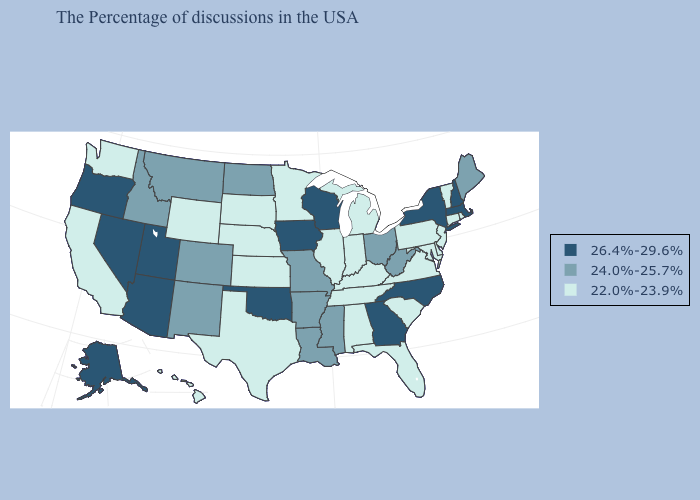Does Minnesota have the lowest value in the USA?
Concise answer only. Yes. What is the value of Arizona?
Quick response, please. 26.4%-29.6%. Name the states that have a value in the range 26.4%-29.6%?
Quick response, please. Massachusetts, New Hampshire, New York, North Carolina, Georgia, Wisconsin, Iowa, Oklahoma, Utah, Arizona, Nevada, Oregon, Alaska. Does Maine have the highest value in the Northeast?
Concise answer only. No. Which states have the lowest value in the USA?
Be succinct. Rhode Island, Vermont, Connecticut, New Jersey, Delaware, Maryland, Pennsylvania, Virginia, South Carolina, Florida, Michigan, Kentucky, Indiana, Alabama, Tennessee, Illinois, Minnesota, Kansas, Nebraska, Texas, South Dakota, Wyoming, California, Washington, Hawaii. Name the states that have a value in the range 22.0%-23.9%?
Be succinct. Rhode Island, Vermont, Connecticut, New Jersey, Delaware, Maryland, Pennsylvania, Virginia, South Carolina, Florida, Michigan, Kentucky, Indiana, Alabama, Tennessee, Illinois, Minnesota, Kansas, Nebraska, Texas, South Dakota, Wyoming, California, Washington, Hawaii. How many symbols are there in the legend?
Keep it brief. 3. What is the value of Illinois?
Write a very short answer. 22.0%-23.9%. Does Wisconsin have the lowest value in the USA?
Keep it brief. No. Does Minnesota have the lowest value in the USA?
Quick response, please. Yes. What is the value of Iowa?
Keep it brief. 26.4%-29.6%. What is the value of Arizona?
Short answer required. 26.4%-29.6%. Does Kentucky have the same value as Oklahoma?
Answer briefly. No. Name the states that have a value in the range 24.0%-25.7%?
Give a very brief answer. Maine, West Virginia, Ohio, Mississippi, Louisiana, Missouri, Arkansas, North Dakota, Colorado, New Mexico, Montana, Idaho. 